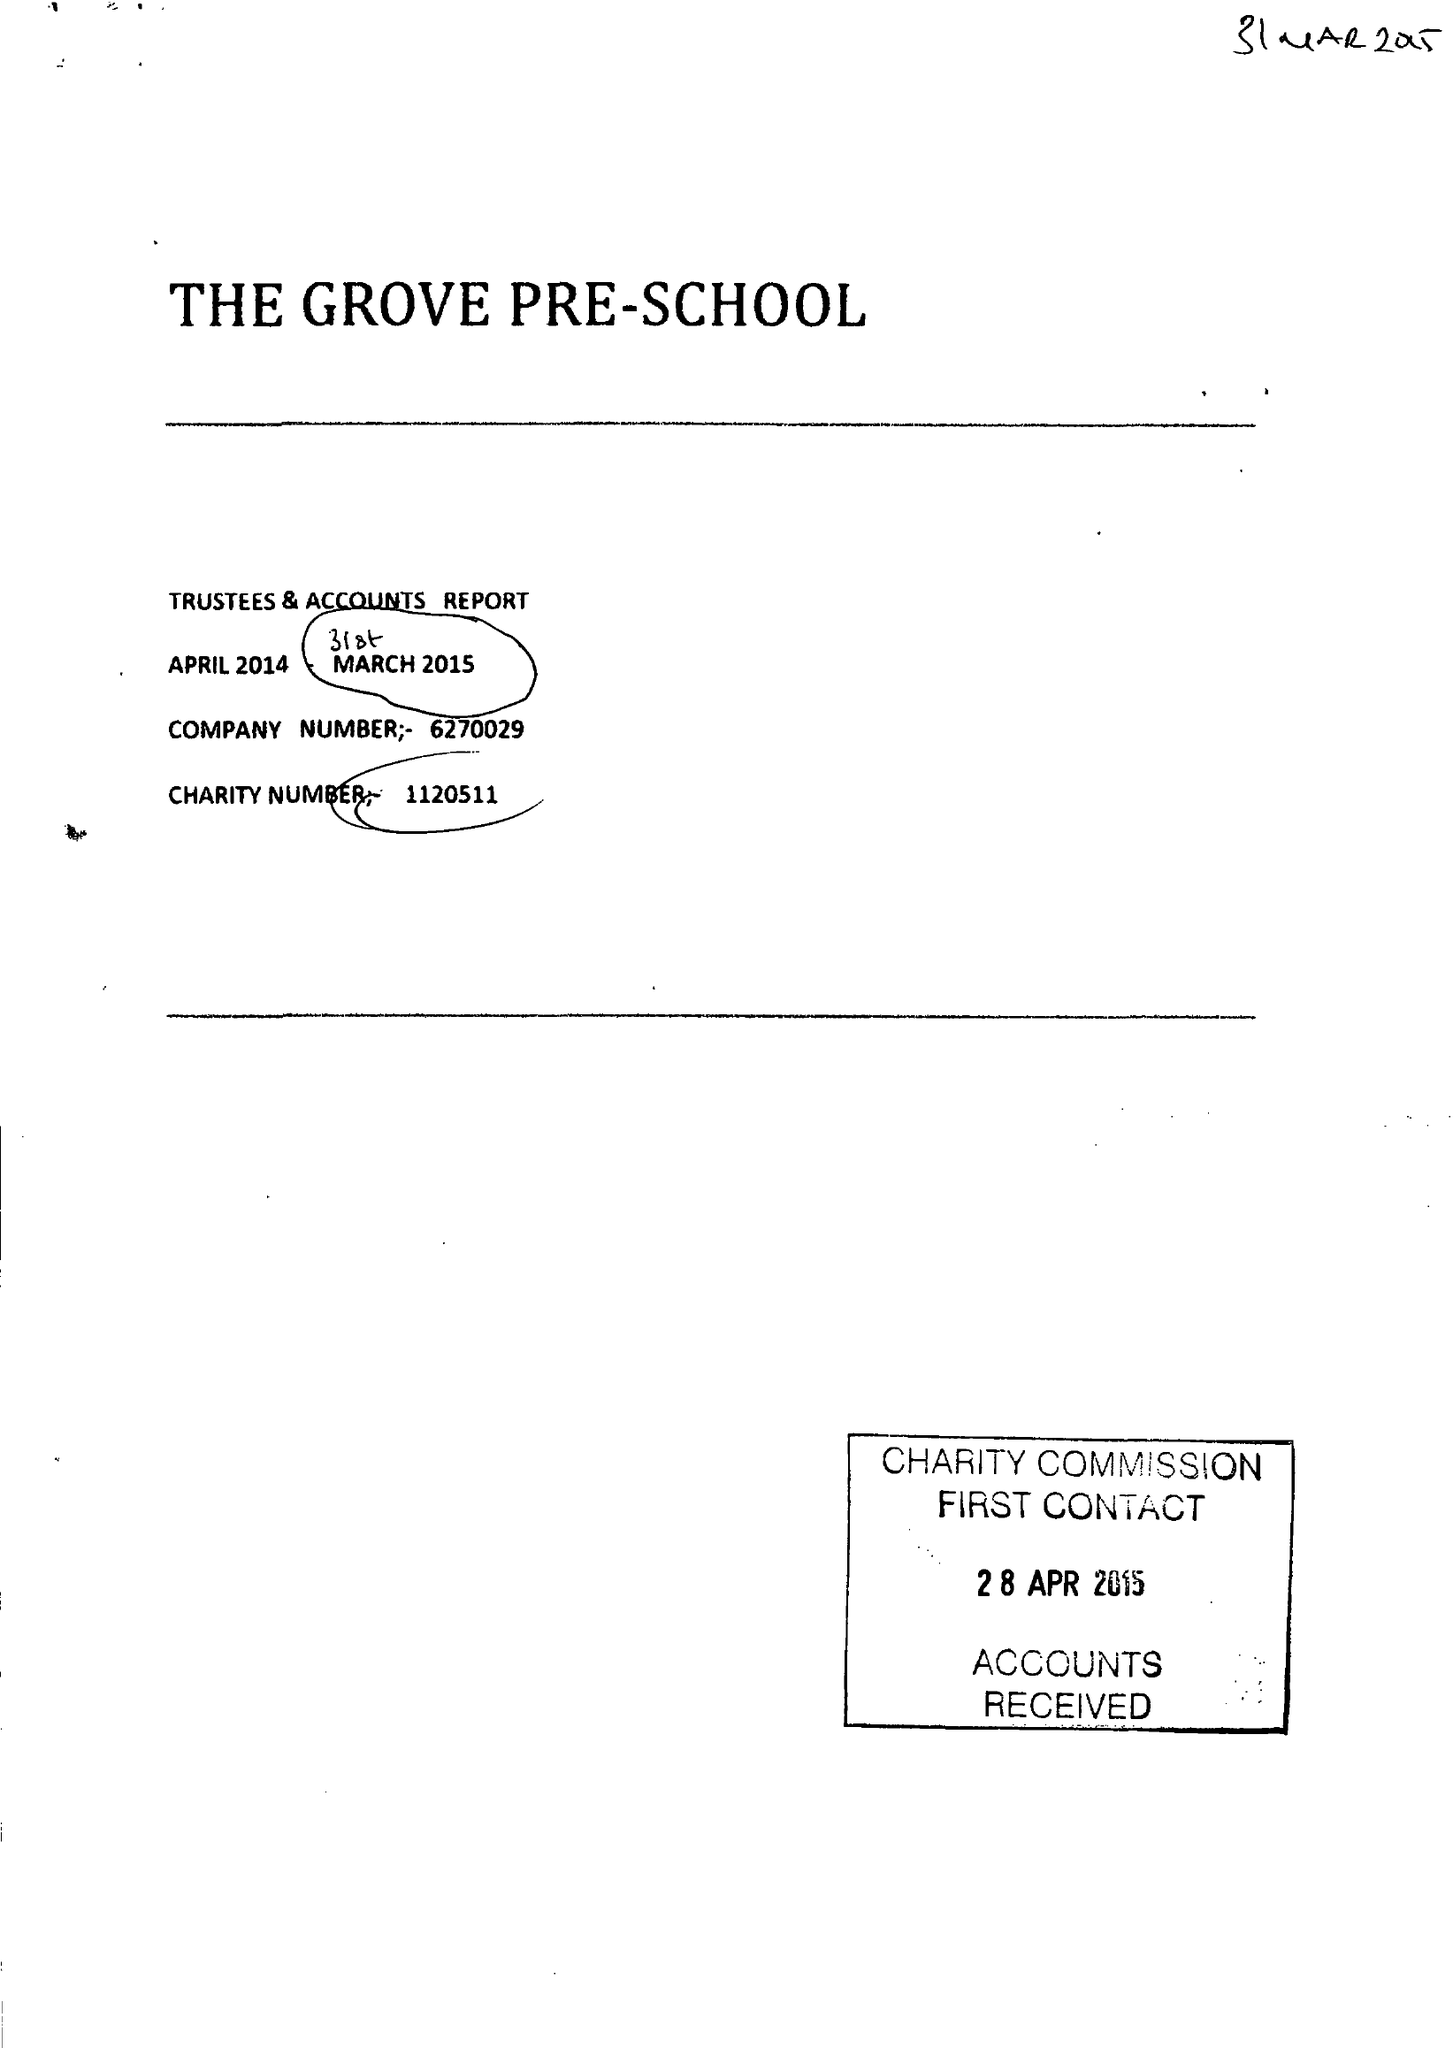What is the value for the address__postcode?
Answer the question using a single word or phrase. DH3 2LN 